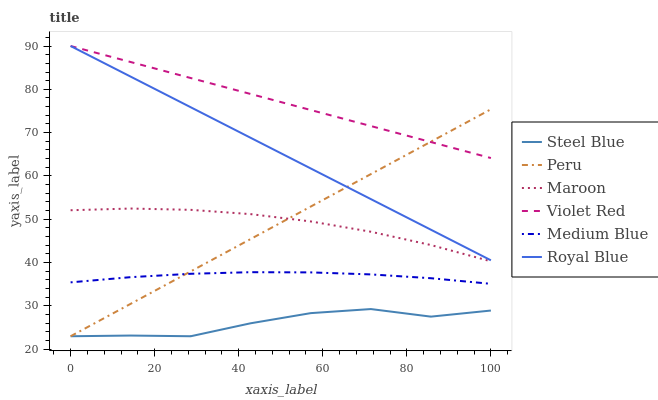Does Medium Blue have the minimum area under the curve?
Answer yes or no. No. Does Medium Blue have the maximum area under the curve?
Answer yes or no. No. Is Medium Blue the smoothest?
Answer yes or no. No. Is Medium Blue the roughest?
Answer yes or no. No. Does Medium Blue have the lowest value?
Answer yes or no. No. Does Medium Blue have the highest value?
Answer yes or no. No. Is Steel Blue less than Royal Blue?
Answer yes or no. Yes. Is Royal Blue greater than Medium Blue?
Answer yes or no. Yes. Does Steel Blue intersect Royal Blue?
Answer yes or no. No. 